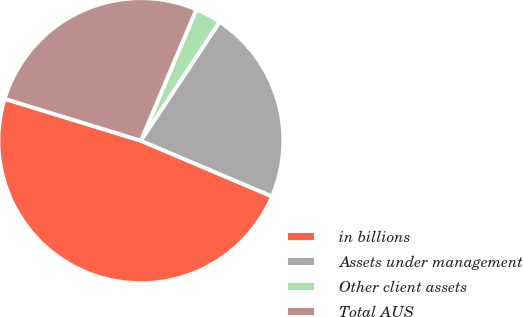Convert chart. <chart><loc_0><loc_0><loc_500><loc_500><pie_chart><fcel>in billions<fcel>Assets under management<fcel>Other client assets<fcel>Total AUS<nl><fcel>48.35%<fcel>22.08%<fcel>2.95%<fcel>26.62%<nl></chart> 